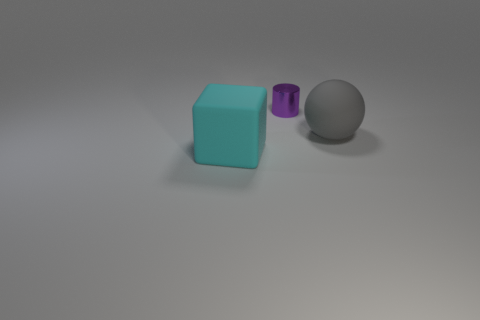Add 3 blue things. How many objects exist? 6 Subtract all spheres. How many objects are left? 2 Subtract all big green shiny cylinders. Subtract all big matte objects. How many objects are left? 1 Add 1 gray rubber objects. How many gray rubber objects are left? 2 Add 2 big purple blocks. How many big purple blocks exist? 2 Subtract 0 brown blocks. How many objects are left? 3 